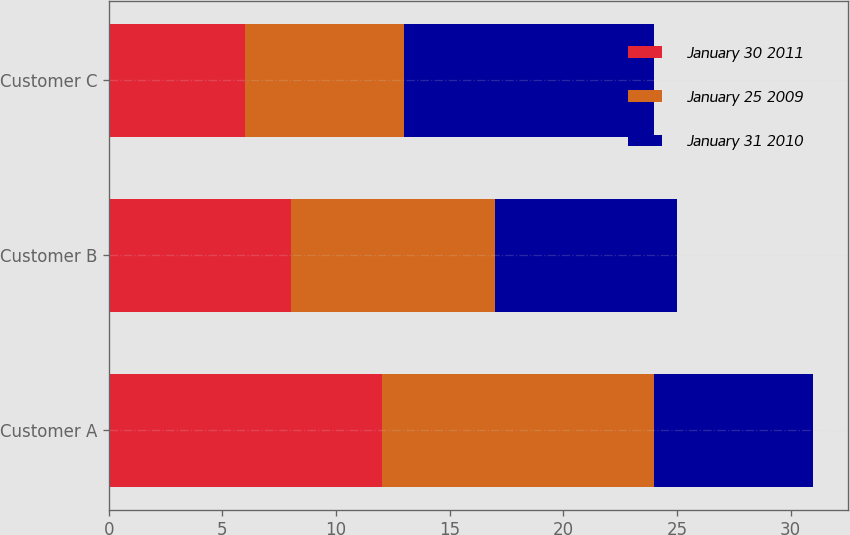Convert chart to OTSL. <chart><loc_0><loc_0><loc_500><loc_500><stacked_bar_chart><ecel><fcel>Customer A<fcel>Customer B<fcel>Customer C<nl><fcel>January 30 2011<fcel>12<fcel>8<fcel>6<nl><fcel>January 25 2009<fcel>12<fcel>9<fcel>7<nl><fcel>January 31 2010<fcel>7<fcel>8<fcel>11<nl></chart> 